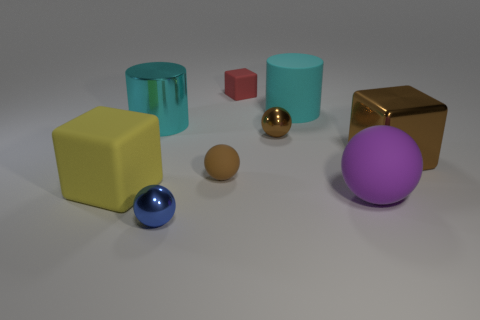What number of metallic spheres are the same size as the yellow rubber cube?
Provide a succinct answer. 0. What is the color of the big rubber object that is both in front of the big brown block and left of the purple rubber object?
Provide a succinct answer. Yellow. What number of objects are either matte cylinders or tiny objects?
Your answer should be compact. 5. What number of big things are blue things or brown objects?
Give a very brief answer. 1. Is there anything else of the same color as the small rubber cube?
Make the answer very short. No. What is the size of the cube that is both left of the big purple ball and behind the big yellow thing?
Keep it short and to the point. Small. Does the large block behind the yellow object have the same color as the matte ball that is behind the big yellow matte thing?
Your answer should be compact. Yes. What number of other objects are there of the same material as the big purple object?
Offer a terse response. 4. What shape is the big object that is both behind the big purple object and in front of the large brown shiny cube?
Offer a terse response. Cube. Do the small rubber sphere and the small metallic sphere that is right of the blue metallic sphere have the same color?
Give a very brief answer. Yes. 